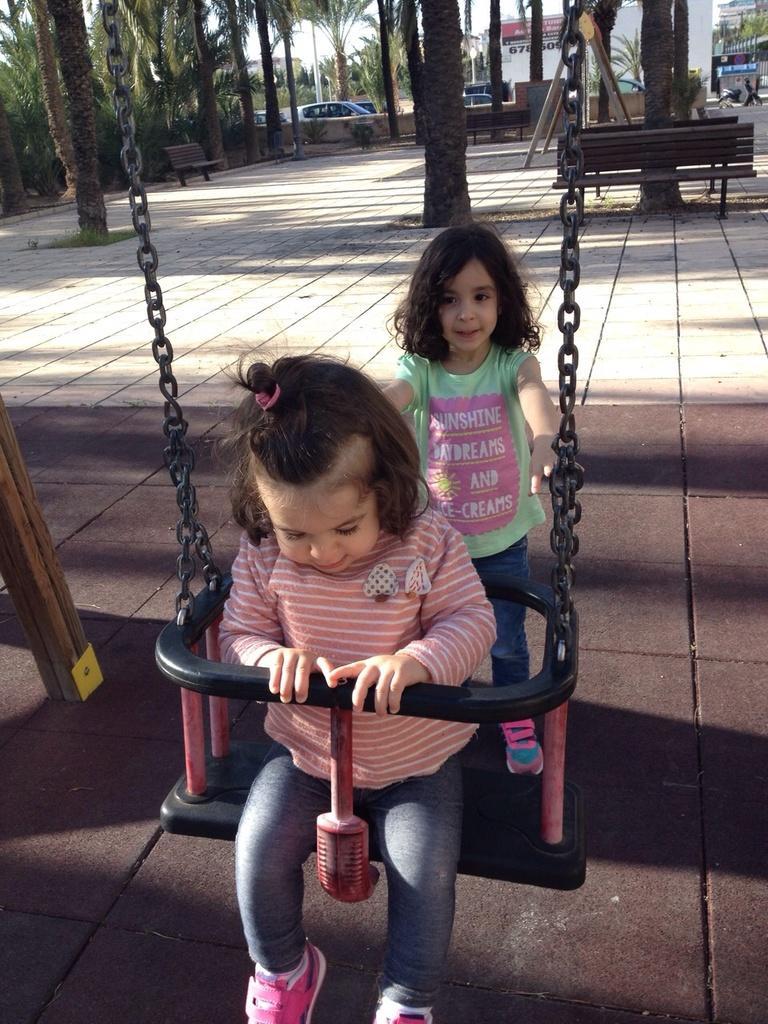In one or two sentences, can you explain what this image depicts? This picture is clicked outside the city. The girl in pink shirt and grey pant is sitting on the swing. Behind her, the girl in green T-shirt is standing and she is holding the swing. Behind her, we see trees and a bench. In the background, we see cars moving on the road. We even see trees and buildings in the background. 